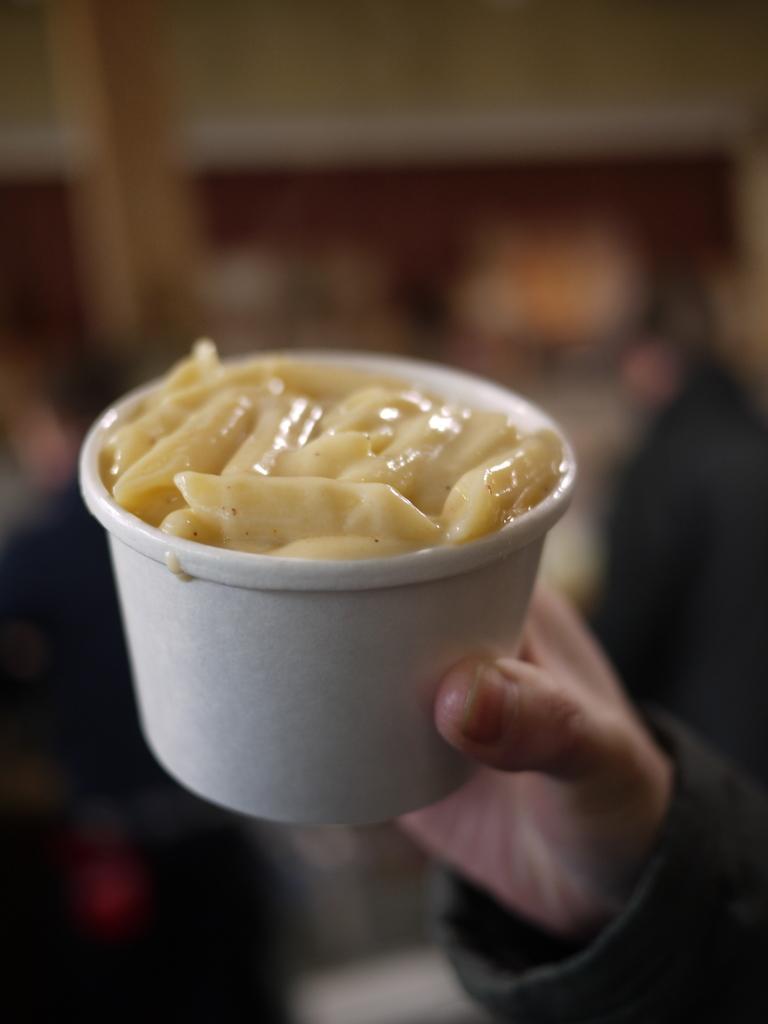Describe this image in one or two sentences. In this image in the foreground there is one person who is holding a cup, and in the cup there is pasta and the background is blurred. 